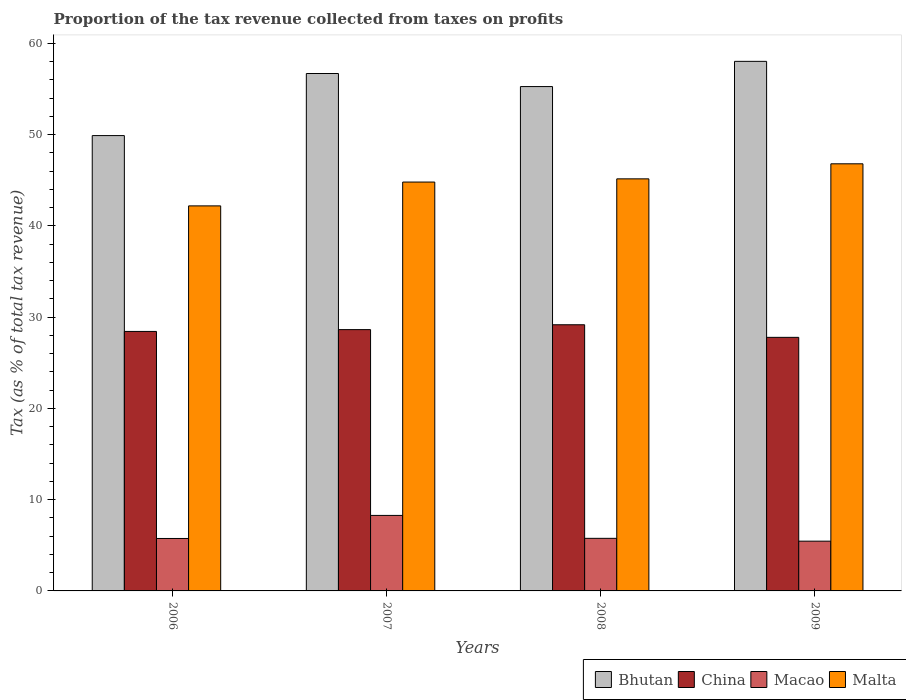How many different coloured bars are there?
Your response must be concise. 4. How many groups of bars are there?
Make the answer very short. 4. Are the number of bars per tick equal to the number of legend labels?
Your response must be concise. Yes. Are the number of bars on each tick of the X-axis equal?
Provide a short and direct response. Yes. How many bars are there on the 4th tick from the right?
Your response must be concise. 4. What is the proportion of the tax revenue collected in Macao in 2006?
Offer a terse response. 5.75. Across all years, what is the maximum proportion of the tax revenue collected in China?
Ensure brevity in your answer.  29.17. Across all years, what is the minimum proportion of the tax revenue collected in Macao?
Offer a very short reply. 5.45. In which year was the proportion of the tax revenue collected in Malta minimum?
Give a very brief answer. 2006. What is the total proportion of the tax revenue collected in Bhutan in the graph?
Offer a terse response. 219.94. What is the difference between the proportion of the tax revenue collected in Malta in 2008 and that in 2009?
Your answer should be very brief. -1.65. What is the difference between the proportion of the tax revenue collected in China in 2007 and the proportion of the tax revenue collected in Malta in 2009?
Your answer should be compact. -18.17. What is the average proportion of the tax revenue collected in Bhutan per year?
Offer a very short reply. 54.99. In the year 2008, what is the difference between the proportion of the tax revenue collected in Bhutan and proportion of the tax revenue collected in Macao?
Offer a very short reply. 49.52. In how many years, is the proportion of the tax revenue collected in China greater than 36 %?
Ensure brevity in your answer.  0. What is the ratio of the proportion of the tax revenue collected in Bhutan in 2006 to that in 2007?
Make the answer very short. 0.88. Is the proportion of the tax revenue collected in Malta in 2007 less than that in 2008?
Ensure brevity in your answer.  Yes. What is the difference between the highest and the second highest proportion of the tax revenue collected in Malta?
Provide a succinct answer. 1.65. What is the difference between the highest and the lowest proportion of the tax revenue collected in China?
Ensure brevity in your answer.  1.38. In how many years, is the proportion of the tax revenue collected in Macao greater than the average proportion of the tax revenue collected in Macao taken over all years?
Offer a very short reply. 1. What does the 3rd bar from the left in 2009 represents?
Provide a short and direct response. Macao. What does the 4th bar from the right in 2006 represents?
Offer a very short reply. Bhutan. Is it the case that in every year, the sum of the proportion of the tax revenue collected in Bhutan and proportion of the tax revenue collected in Malta is greater than the proportion of the tax revenue collected in China?
Give a very brief answer. Yes. How many bars are there?
Your answer should be compact. 16. Are all the bars in the graph horizontal?
Ensure brevity in your answer.  No. How many years are there in the graph?
Offer a terse response. 4. What is the difference between two consecutive major ticks on the Y-axis?
Provide a succinct answer. 10. Are the values on the major ticks of Y-axis written in scientific E-notation?
Provide a short and direct response. No. Does the graph contain any zero values?
Your response must be concise. No. How many legend labels are there?
Offer a terse response. 4. How are the legend labels stacked?
Provide a short and direct response. Horizontal. What is the title of the graph?
Provide a short and direct response. Proportion of the tax revenue collected from taxes on profits. Does "Singapore" appear as one of the legend labels in the graph?
Your answer should be very brief. No. What is the label or title of the X-axis?
Keep it short and to the point. Years. What is the label or title of the Y-axis?
Offer a very short reply. Tax (as % of total tax revenue). What is the Tax (as % of total tax revenue) in Bhutan in 2006?
Offer a terse response. 49.91. What is the Tax (as % of total tax revenue) of China in 2006?
Provide a succinct answer. 28.44. What is the Tax (as % of total tax revenue) in Macao in 2006?
Offer a very short reply. 5.75. What is the Tax (as % of total tax revenue) in Malta in 2006?
Keep it short and to the point. 42.2. What is the Tax (as % of total tax revenue) in Bhutan in 2007?
Keep it short and to the point. 56.71. What is the Tax (as % of total tax revenue) in China in 2007?
Make the answer very short. 28.64. What is the Tax (as % of total tax revenue) of Macao in 2007?
Offer a very short reply. 8.28. What is the Tax (as % of total tax revenue) in Malta in 2007?
Provide a succinct answer. 44.81. What is the Tax (as % of total tax revenue) in Bhutan in 2008?
Your answer should be compact. 55.28. What is the Tax (as % of total tax revenue) in China in 2008?
Keep it short and to the point. 29.17. What is the Tax (as % of total tax revenue) in Macao in 2008?
Ensure brevity in your answer.  5.76. What is the Tax (as % of total tax revenue) in Malta in 2008?
Ensure brevity in your answer.  45.16. What is the Tax (as % of total tax revenue) of Bhutan in 2009?
Your answer should be very brief. 58.04. What is the Tax (as % of total tax revenue) in China in 2009?
Keep it short and to the point. 27.79. What is the Tax (as % of total tax revenue) of Macao in 2009?
Make the answer very short. 5.45. What is the Tax (as % of total tax revenue) of Malta in 2009?
Ensure brevity in your answer.  46.81. Across all years, what is the maximum Tax (as % of total tax revenue) in Bhutan?
Your answer should be compact. 58.04. Across all years, what is the maximum Tax (as % of total tax revenue) in China?
Ensure brevity in your answer.  29.17. Across all years, what is the maximum Tax (as % of total tax revenue) in Macao?
Make the answer very short. 8.28. Across all years, what is the maximum Tax (as % of total tax revenue) in Malta?
Give a very brief answer. 46.81. Across all years, what is the minimum Tax (as % of total tax revenue) in Bhutan?
Give a very brief answer. 49.91. Across all years, what is the minimum Tax (as % of total tax revenue) in China?
Offer a very short reply. 27.79. Across all years, what is the minimum Tax (as % of total tax revenue) of Macao?
Your answer should be compact. 5.45. Across all years, what is the minimum Tax (as % of total tax revenue) in Malta?
Ensure brevity in your answer.  42.2. What is the total Tax (as % of total tax revenue) of Bhutan in the graph?
Provide a short and direct response. 219.94. What is the total Tax (as % of total tax revenue) of China in the graph?
Your answer should be very brief. 114.05. What is the total Tax (as % of total tax revenue) of Macao in the graph?
Ensure brevity in your answer.  25.24. What is the total Tax (as % of total tax revenue) in Malta in the graph?
Keep it short and to the point. 179. What is the difference between the Tax (as % of total tax revenue) of Bhutan in 2006 and that in 2007?
Keep it short and to the point. -6.81. What is the difference between the Tax (as % of total tax revenue) of China in 2006 and that in 2007?
Your answer should be very brief. -0.2. What is the difference between the Tax (as % of total tax revenue) of Macao in 2006 and that in 2007?
Offer a very short reply. -2.53. What is the difference between the Tax (as % of total tax revenue) of Malta in 2006 and that in 2007?
Keep it short and to the point. -2.61. What is the difference between the Tax (as % of total tax revenue) of Bhutan in 2006 and that in 2008?
Your response must be concise. -5.37. What is the difference between the Tax (as % of total tax revenue) of China in 2006 and that in 2008?
Ensure brevity in your answer.  -0.73. What is the difference between the Tax (as % of total tax revenue) of Macao in 2006 and that in 2008?
Offer a very short reply. -0.02. What is the difference between the Tax (as % of total tax revenue) of Malta in 2006 and that in 2008?
Your answer should be compact. -2.96. What is the difference between the Tax (as % of total tax revenue) of Bhutan in 2006 and that in 2009?
Your answer should be compact. -8.14. What is the difference between the Tax (as % of total tax revenue) of China in 2006 and that in 2009?
Your response must be concise. 0.65. What is the difference between the Tax (as % of total tax revenue) of Macao in 2006 and that in 2009?
Your answer should be very brief. 0.3. What is the difference between the Tax (as % of total tax revenue) of Malta in 2006 and that in 2009?
Offer a terse response. -4.61. What is the difference between the Tax (as % of total tax revenue) of Bhutan in 2007 and that in 2008?
Offer a terse response. 1.43. What is the difference between the Tax (as % of total tax revenue) of China in 2007 and that in 2008?
Offer a terse response. -0.53. What is the difference between the Tax (as % of total tax revenue) in Macao in 2007 and that in 2008?
Give a very brief answer. 2.51. What is the difference between the Tax (as % of total tax revenue) of Malta in 2007 and that in 2008?
Make the answer very short. -0.35. What is the difference between the Tax (as % of total tax revenue) of Bhutan in 2007 and that in 2009?
Provide a succinct answer. -1.33. What is the difference between the Tax (as % of total tax revenue) of China in 2007 and that in 2009?
Make the answer very short. 0.85. What is the difference between the Tax (as % of total tax revenue) of Macao in 2007 and that in 2009?
Give a very brief answer. 2.82. What is the difference between the Tax (as % of total tax revenue) of Malta in 2007 and that in 2009?
Provide a short and direct response. -2. What is the difference between the Tax (as % of total tax revenue) in Bhutan in 2008 and that in 2009?
Provide a short and direct response. -2.76. What is the difference between the Tax (as % of total tax revenue) in China in 2008 and that in 2009?
Provide a succinct answer. 1.38. What is the difference between the Tax (as % of total tax revenue) in Macao in 2008 and that in 2009?
Make the answer very short. 0.31. What is the difference between the Tax (as % of total tax revenue) of Malta in 2008 and that in 2009?
Ensure brevity in your answer.  -1.65. What is the difference between the Tax (as % of total tax revenue) of Bhutan in 2006 and the Tax (as % of total tax revenue) of China in 2007?
Provide a short and direct response. 21.27. What is the difference between the Tax (as % of total tax revenue) of Bhutan in 2006 and the Tax (as % of total tax revenue) of Macao in 2007?
Your answer should be very brief. 41.63. What is the difference between the Tax (as % of total tax revenue) in Bhutan in 2006 and the Tax (as % of total tax revenue) in Malta in 2007?
Your answer should be compact. 5.09. What is the difference between the Tax (as % of total tax revenue) in China in 2006 and the Tax (as % of total tax revenue) in Macao in 2007?
Give a very brief answer. 20.17. What is the difference between the Tax (as % of total tax revenue) of China in 2006 and the Tax (as % of total tax revenue) of Malta in 2007?
Give a very brief answer. -16.37. What is the difference between the Tax (as % of total tax revenue) of Macao in 2006 and the Tax (as % of total tax revenue) of Malta in 2007?
Provide a short and direct response. -39.07. What is the difference between the Tax (as % of total tax revenue) of Bhutan in 2006 and the Tax (as % of total tax revenue) of China in 2008?
Ensure brevity in your answer.  20.73. What is the difference between the Tax (as % of total tax revenue) in Bhutan in 2006 and the Tax (as % of total tax revenue) in Macao in 2008?
Your response must be concise. 44.14. What is the difference between the Tax (as % of total tax revenue) in Bhutan in 2006 and the Tax (as % of total tax revenue) in Malta in 2008?
Ensure brevity in your answer.  4.74. What is the difference between the Tax (as % of total tax revenue) in China in 2006 and the Tax (as % of total tax revenue) in Macao in 2008?
Your response must be concise. 22.68. What is the difference between the Tax (as % of total tax revenue) in China in 2006 and the Tax (as % of total tax revenue) in Malta in 2008?
Offer a terse response. -16.72. What is the difference between the Tax (as % of total tax revenue) of Macao in 2006 and the Tax (as % of total tax revenue) of Malta in 2008?
Keep it short and to the point. -39.42. What is the difference between the Tax (as % of total tax revenue) in Bhutan in 2006 and the Tax (as % of total tax revenue) in China in 2009?
Ensure brevity in your answer.  22.11. What is the difference between the Tax (as % of total tax revenue) in Bhutan in 2006 and the Tax (as % of total tax revenue) in Macao in 2009?
Your answer should be very brief. 44.45. What is the difference between the Tax (as % of total tax revenue) of Bhutan in 2006 and the Tax (as % of total tax revenue) of Malta in 2009?
Provide a short and direct response. 3.09. What is the difference between the Tax (as % of total tax revenue) in China in 2006 and the Tax (as % of total tax revenue) in Macao in 2009?
Keep it short and to the point. 22.99. What is the difference between the Tax (as % of total tax revenue) of China in 2006 and the Tax (as % of total tax revenue) of Malta in 2009?
Keep it short and to the point. -18.37. What is the difference between the Tax (as % of total tax revenue) of Macao in 2006 and the Tax (as % of total tax revenue) of Malta in 2009?
Ensure brevity in your answer.  -41.06. What is the difference between the Tax (as % of total tax revenue) in Bhutan in 2007 and the Tax (as % of total tax revenue) in China in 2008?
Offer a terse response. 27.54. What is the difference between the Tax (as % of total tax revenue) of Bhutan in 2007 and the Tax (as % of total tax revenue) of Macao in 2008?
Provide a short and direct response. 50.95. What is the difference between the Tax (as % of total tax revenue) of Bhutan in 2007 and the Tax (as % of total tax revenue) of Malta in 2008?
Ensure brevity in your answer.  11.55. What is the difference between the Tax (as % of total tax revenue) in China in 2007 and the Tax (as % of total tax revenue) in Macao in 2008?
Ensure brevity in your answer.  22.88. What is the difference between the Tax (as % of total tax revenue) in China in 2007 and the Tax (as % of total tax revenue) in Malta in 2008?
Offer a very short reply. -16.52. What is the difference between the Tax (as % of total tax revenue) of Macao in 2007 and the Tax (as % of total tax revenue) of Malta in 2008?
Make the answer very short. -36.89. What is the difference between the Tax (as % of total tax revenue) of Bhutan in 2007 and the Tax (as % of total tax revenue) of China in 2009?
Provide a succinct answer. 28.92. What is the difference between the Tax (as % of total tax revenue) of Bhutan in 2007 and the Tax (as % of total tax revenue) of Macao in 2009?
Provide a succinct answer. 51.26. What is the difference between the Tax (as % of total tax revenue) in Bhutan in 2007 and the Tax (as % of total tax revenue) in Malta in 2009?
Ensure brevity in your answer.  9.9. What is the difference between the Tax (as % of total tax revenue) in China in 2007 and the Tax (as % of total tax revenue) in Macao in 2009?
Your answer should be very brief. 23.19. What is the difference between the Tax (as % of total tax revenue) in China in 2007 and the Tax (as % of total tax revenue) in Malta in 2009?
Offer a very short reply. -18.17. What is the difference between the Tax (as % of total tax revenue) of Macao in 2007 and the Tax (as % of total tax revenue) of Malta in 2009?
Your answer should be compact. -38.54. What is the difference between the Tax (as % of total tax revenue) of Bhutan in 2008 and the Tax (as % of total tax revenue) of China in 2009?
Offer a terse response. 27.49. What is the difference between the Tax (as % of total tax revenue) in Bhutan in 2008 and the Tax (as % of total tax revenue) in Macao in 2009?
Offer a terse response. 49.83. What is the difference between the Tax (as % of total tax revenue) of Bhutan in 2008 and the Tax (as % of total tax revenue) of Malta in 2009?
Offer a very short reply. 8.47. What is the difference between the Tax (as % of total tax revenue) of China in 2008 and the Tax (as % of total tax revenue) of Macao in 2009?
Your response must be concise. 23.72. What is the difference between the Tax (as % of total tax revenue) in China in 2008 and the Tax (as % of total tax revenue) in Malta in 2009?
Make the answer very short. -17.64. What is the difference between the Tax (as % of total tax revenue) of Macao in 2008 and the Tax (as % of total tax revenue) of Malta in 2009?
Ensure brevity in your answer.  -41.05. What is the average Tax (as % of total tax revenue) in Bhutan per year?
Offer a very short reply. 54.99. What is the average Tax (as % of total tax revenue) in China per year?
Provide a succinct answer. 28.51. What is the average Tax (as % of total tax revenue) of Macao per year?
Offer a very short reply. 6.31. What is the average Tax (as % of total tax revenue) in Malta per year?
Your answer should be very brief. 44.75. In the year 2006, what is the difference between the Tax (as % of total tax revenue) of Bhutan and Tax (as % of total tax revenue) of China?
Your response must be concise. 21.47. In the year 2006, what is the difference between the Tax (as % of total tax revenue) in Bhutan and Tax (as % of total tax revenue) in Macao?
Ensure brevity in your answer.  44.16. In the year 2006, what is the difference between the Tax (as % of total tax revenue) of Bhutan and Tax (as % of total tax revenue) of Malta?
Keep it short and to the point. 7.7. In the year 2006, what is the difference between the Tax (as % of total tax revenue) in China and Tax (as % of total tax revenue) in Macao?
Offer a very short reply. 22.69. In the year 2006, what is the difference between the Tax (as % of total tax revenue) of China and Tax (as % of total tax revenue) of Malta?
Give a very brief answer. -13.76. In the year 2006, what is the difference between the Tax (as % of total tax revenue) of Macao and Tax (as % of total tax revenue) of Malta?
Provide a succinct answer. -36.45. In the year 2007, what is the difference between the Tax (as % of total tax revenue) in Bhutan and Tax (as % of total tax revenue) in China?
Ensure brevity in your answer.  28.07. In the year 2007, what is the difference between the Tax (as % of total tax revenue) of Bhutan and Tax (as % of total tax revenue) of Macao?
Provide a short and direct response. 48.44. In the year 2007, what is the difference between the Tax (as % of total tax revenue) of Bhutan and Tax (as % of total tax revenue) of Malta?
Your answer should be compact. 11.9. In the year 2007, what is the difference between the Tax (as % of total tax revenue) in China and Tax (as % of total tax revenue) in Macao?
Offer a very short reply. 20.37. In the year 2007, what is the difference between the Tax (as % of total tax revenue) of China and Tax (as % of total tax revenue) of Malta?
Your answer should be very brief. -16.17. In the year 2007, what is the difference between the Tax (as % of total tax revenue) of Macao and Tax (as % of total tax revenue) of Malta?
Your answer should be compact. -36.54. In the year 2008, what is the difference between the Tax (as % of total tax revenue) in Bhutan and Tax (as % of total tax revenue) in China?
Keep it short and to the point. 26.11. In the year 2008, what is the difference between the Tax (as % of total tax revenue) of Bhutan and Tax (as % of total tax revenue) of Macao?
Offer a terse response. 49.52. In the year 2008, what is the difference between the Tax (as % of total tax revenue) in Bhutan and Tax (as % of total tax revenue) in Malta?
Ensure brevity in your answer.  10.12. In the year 2008, what is the difference between the Tax (as % of total tax revenue) in China and Tax (as % of total tax revenue) in Macao?
Your response must be concise. 23.41. In the year 2008, what is the difference between the Tax (as % of total tax revenue) of China and Tax (as % of total tax revenue) of Malta?
Offer a terse response. -15.99. In the year 2008, what is the difference between the Tax (as % of total tax revenue) of Macao and Tax (as % of total tax revenue) of Malta?
Your answer should be compact. -39.4. In the year 2009, what is the difference between the Tax (as % of total tax revenue) in Bhutan and Tax (as % of total tax revenue) in China?
Offer a terse response. 30.25. In the year 2009, what is the difference between the Tax (as % of total tax revenue) of Bhutan and Tax (as % of total tax revenue) of Macao?
Offer a very short reply. 52.59. In the year 2009, what is the difference between the Tax (as % of total tax revenue) of Bhutan and Tax (as % of total tax revenue) of Malta?
Keep it short and to the point. 11.23. In the year 2009, what is the difference between the Tax (as % of total tax revenue) of China and Tax (as % of total tax revenue) of Macao?
Offer a very short reply. 22.34. In the year 2009, what is the difference between the Tax (as % of total tax revenue) of China and Tax (as % of total tax revenue) of Malta?
Keep it short and to the point. -19.02. In the year 2009, what is the difference between the Tax (as % of total tax revenue) of Macao and Tax (as % of total tax revenue) of Malta?
Provide a short and direct response. -41.36. What is the ratio of the Tax (as % of total tax revenue) in Bhutan in 2006 to that in 2007?
Make the answer very short. 0.88. What is the ratio of the Tax (as % of total tax revenue) of Macao in 2006 to that in 2007?
Your response must be concise. 0.69. What is the ratio of the Tax (as % of total tax revenue) in Malta in 2006 to that in 2007?
Keep it short and to the point. 0.94. What is the ratio of the Tax (as % of total tax revenue) of Bhutan in 2006 to that in 2008?
Provide a succinct answer. 0.9. What is the ratio of the Tax (as % of total tax revenue) of China in 2006 to that in 2008?
Provide a succinct answer. 0.97. What is the ratio of the Tax (as % of total tax revenue) in Macao in 2006 to that in 2008?
Your response must be concise. 1. What is the ratio of the Tax (as % of total tax revenue) of Malta in 2006 to that in 2008?
Provide a succinct answer. 0.93. What is the ratio of the Tax (as % of total tax revenue) of Bhutan in 2006 to that in 2009?
Keep it short and to the point. 0.86. What is the ratio of the Tax (as % of total tax revenue) in China in 2006 to that in 2009?
Your answer should be very brief. 1.02. What is the ratio of the Tax (as % of total tax revenue) of Macao in 2006 to that in 2009?
Ensure brevity in your answer.  1.05. What is the ratio of the Tax (as % of total tax revenue) of Malta in 2006 to that in 2009?
Ensure brevity in your answer.  0.9. What is the ratio of the Tax (as % of total tax revenue) of Bhutan in 2007 to that in 2008?
Provide a short and direct response. 1.03. What is the ratio of the Tax (as % of total tax revenue) in China in 2007 to that in 2008?
Provide a short and direct response. 0.98. What is the ratio of the Tax (as % of total tax revenue) of Macao in 2007 to that in 2008?
Your response must be concise. 1.44. What is the ratio of the Tax (as % of total tax revenue) in Malta in 2007 to that in 2008?
Offer a terse response. 0.99. What is the ratio of the Tax (as % of total tax revenue) of Bhutan in 2007 to that in 2009?
Your answer should be compact. 0.98. What is the ratio of the Tax (as % of total tax revenue) of China in 2007 to that in 2009?
Offer a very short reply. 1.03. What is the ratio of the Tax (as % of total tax revenue) in Macao in 2007 to that in 2009?
Offer a terse response. 1.52. What is the ratio of the Tax (as % of total tax revenue) in Malta in 2007 to that in 2009?
Your answer should be very brief. 0.96. What is the ratio of the Tax (as % of total tax revenue) in Bhutan in 2008 to that in 2009?
Give a very brief answer. 0.95. What is the ratio of the Tax (as % of total tax revenue) of China in 2008 to that in 2009?
Provide a succinct answer. 1.05. What is the ratio of the Tax (as % of total tax revenue) of Macao in 2008 to that in 2009?
Your answer should be compact. 1.06. What is the ratio of the Tax (as % of total tax revenue) of Malta in 2008 to that in 2009?
Provide a succinct answer. 0.96. What is the difference between the highest and the second highest Tax (as % of total tax revenue) of Bhutan?
Keep it short and to the point. 1.33. What is the difference between the highest and the second highest Tax (as % of total tax revenue) of China?
Provide a succinct answer. 0.53. What is the difference between the highest and the second highest Tax (as % of total tax revenue) in Macao?
Keep it short and to the point. 2.51. What is the difference between the highest and the second highest Tax (as % of total tax revenue) in Malta?
Make the answer very short. 1.65. What is the difference between the highest and the lowest Tax (as % of total tax revenue) of Bhutan?
Your answer should be compact. 8.14. What is the difference between the highest and the lowest Tax (as % of total tax revenue) of China?
Provide a succinct answer. 1.38. What is the difference between the highest and the lowest Tax (as % of total tax revenue) of Macao?
Your response must be concise. 2.82. What is the difference between the highest and the lowest Tax (as % of total tax revenue) of Malta?
Your answer should be very brief. 4.61. 